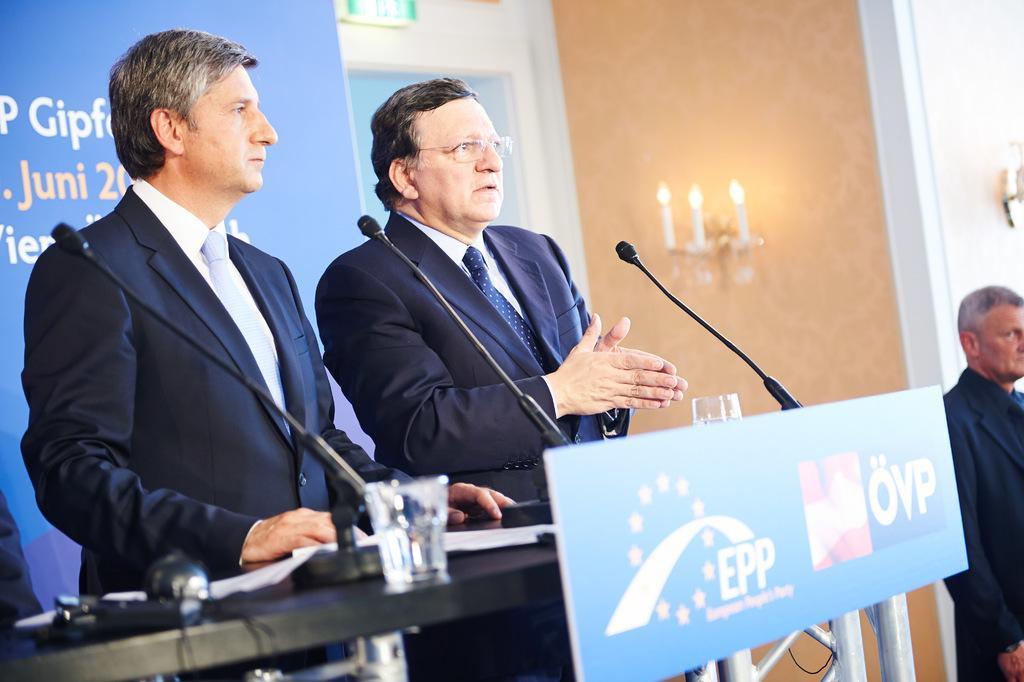Can you describe this image briefly? In this image we can see three persons, two of them are standing near the table, there are mice, glasses with water and few other objects on the table and a board with text attached to the table, there is a banner with text in the background and there are lights attached to the wall on the right side of the image. 